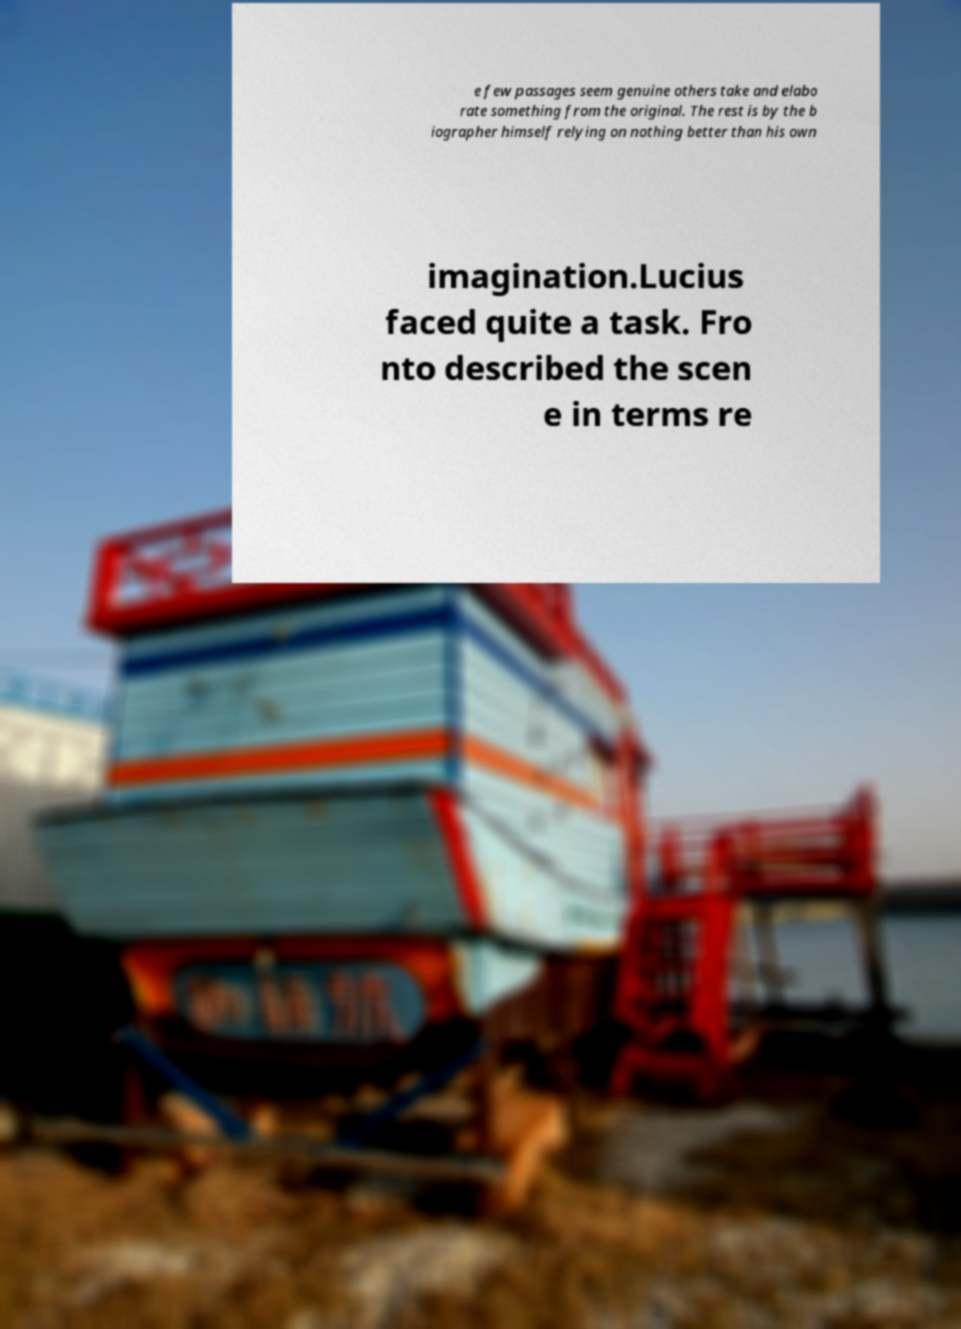For documentation purposes, I need the text within this image transcribed. Could you provide that? e few passages seem genuine others take and elabo rate something from the original. The rest is by the b iographer himself relying on nothing better than his own imagination.Lucius faced quite a task. Fro nto described the scen e in terms re 